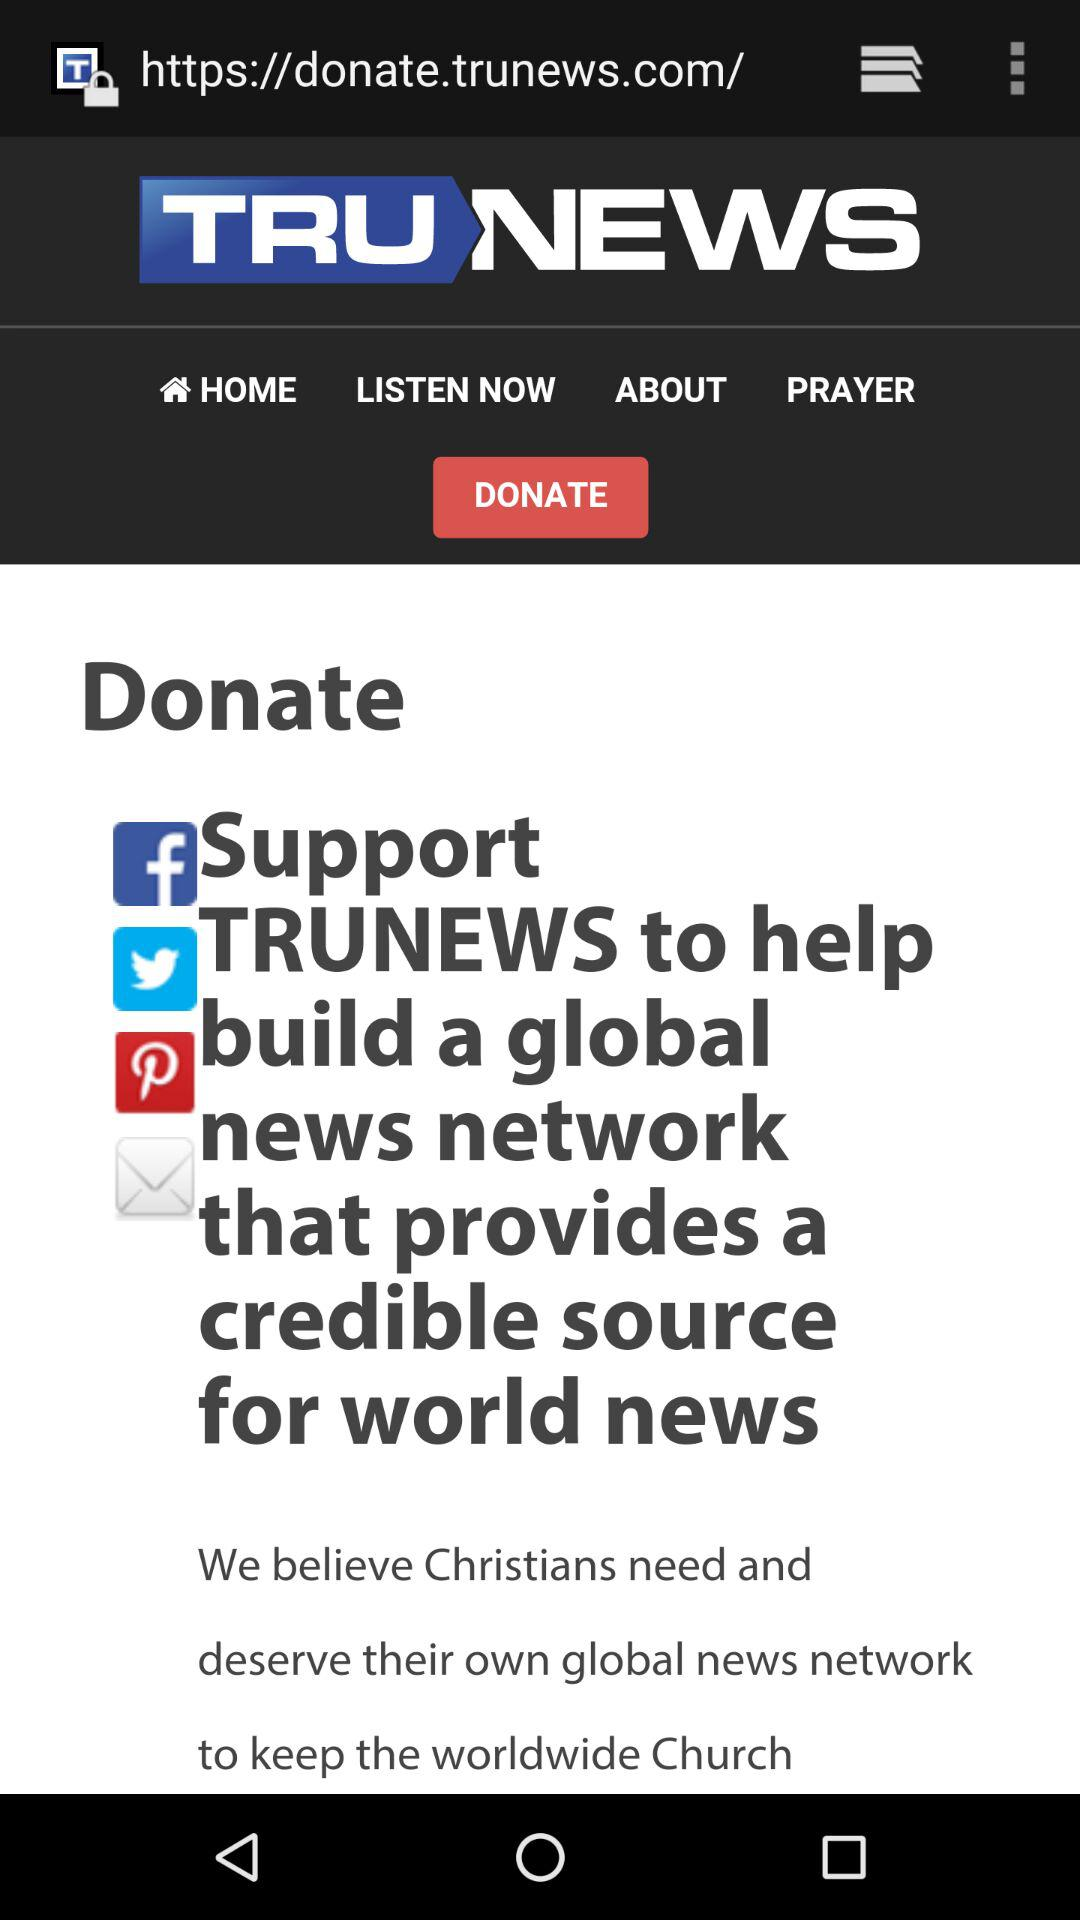What is the headline of the news? The headline is "Support TRUNEWS to help build a global news network that provides a credible source for world news". 